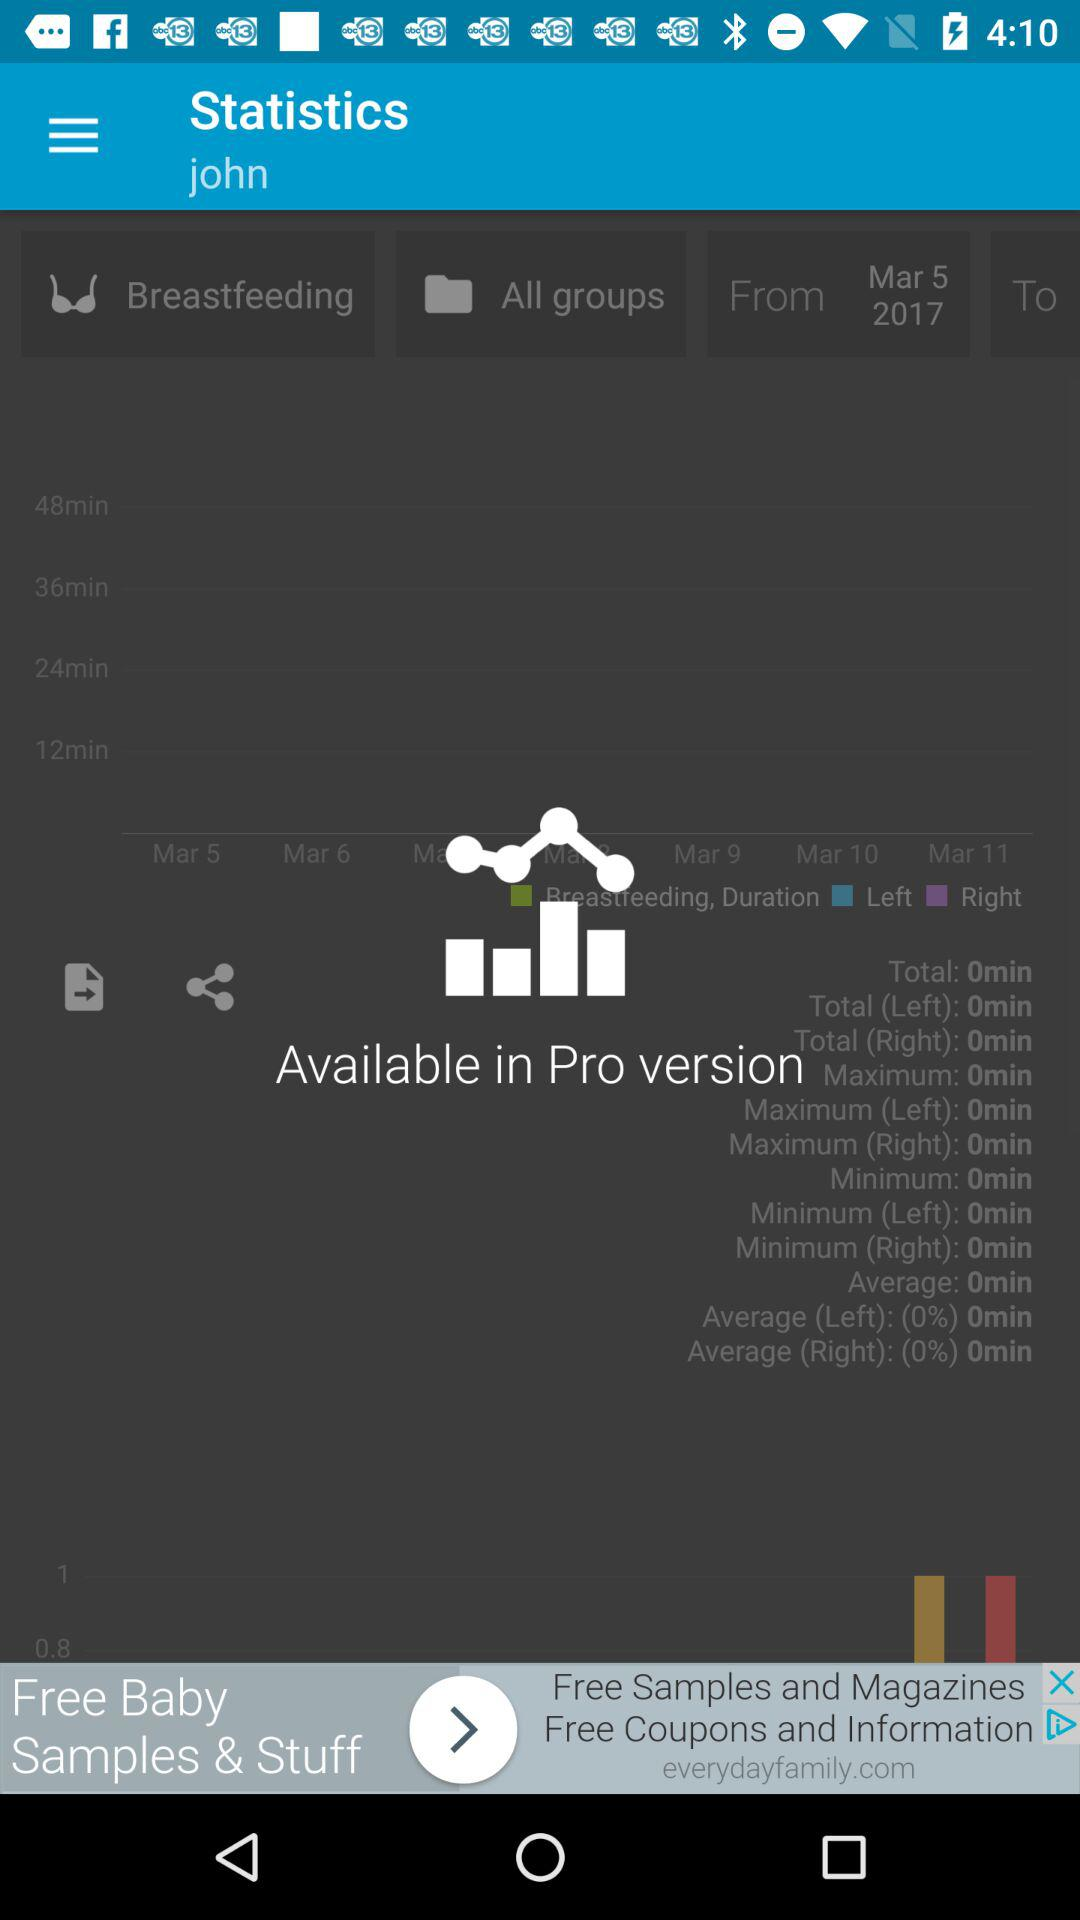What is the application name?
When the provided information is insufficient, respond with <no answer>. <no answer> 